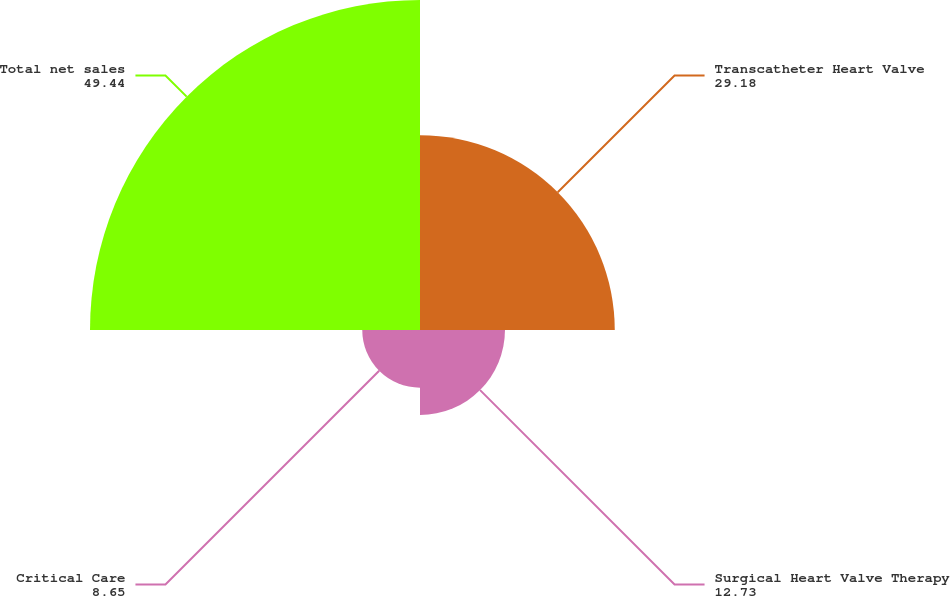Convert chart. <chart><loc_0><loc_0><loc_500><loc_500><pie_chart><fcel>Transcatheter Heart Valve<fcel>Surgical Heart Valve Therapy<fcel>Critical Care<fcel>Total net sales<nl><fcel>29.18%<fcel>12.73%<fcel>8.65%<fcel>49.44%<nl></chart> 